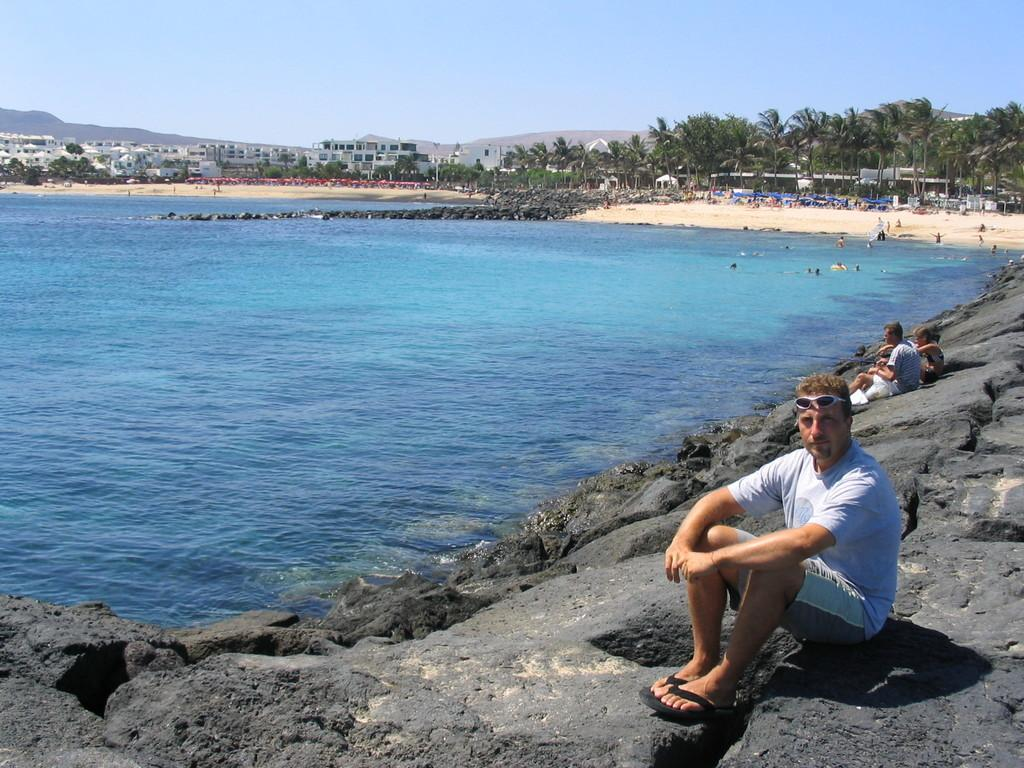What are the people in the image doing? The people in the image are sitting on a rock. What type of vegetation can be seen in the image? There are trees in the image. What natural element is visible in the image? There is water visible in the image. What can be seen in the background of the image? There are buildings and the sky visible in the background of the image. What type of juice is being served on the beds in the image? There are no beds or juice present in the image. 